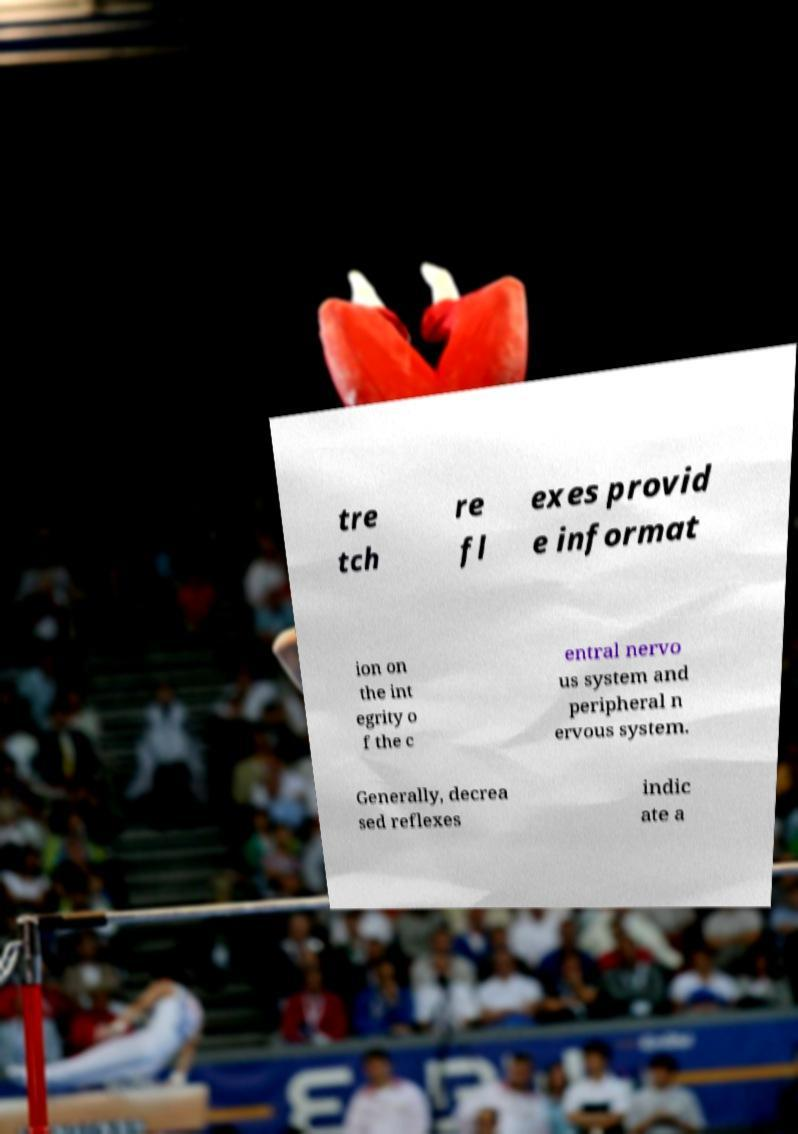Could you extract and type out the text from this image? tre tch re fl exes provid e informat ion on the int egrity o f the c entral nervo us system and peripheral n ervous system. Generally, decrea sed reflexes indic ate a 